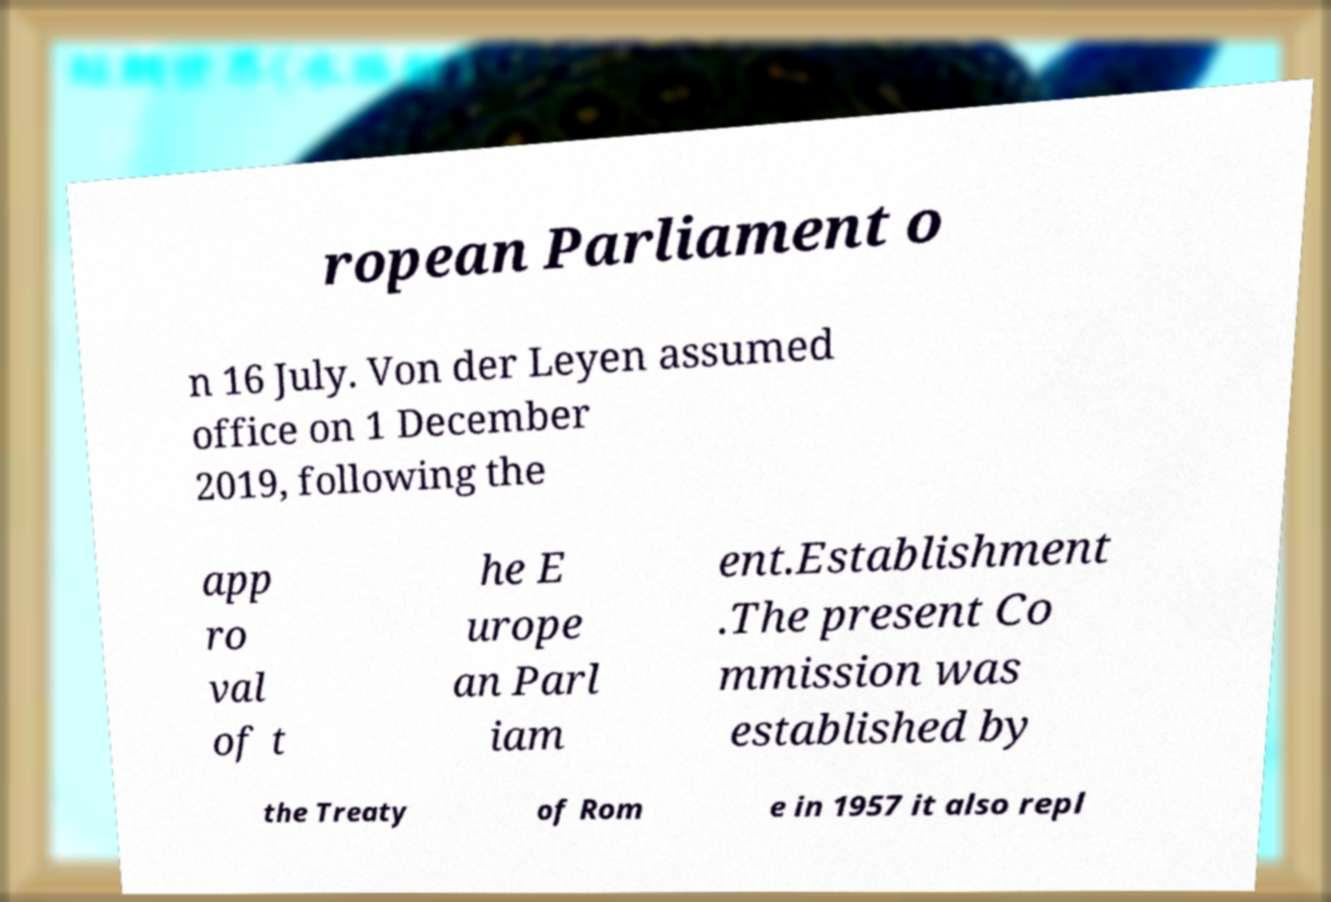Could you assist in decoding the text presented in this image and type it out clearly? ropean Parliament o n 16 July. Von der Leyen assumed office on 1 December 2019, following the app ro val of t he E urope an Parl iam ent.Establishment .The present Co mmission was established by the Treaty of Rom e in 1957 it also repl 